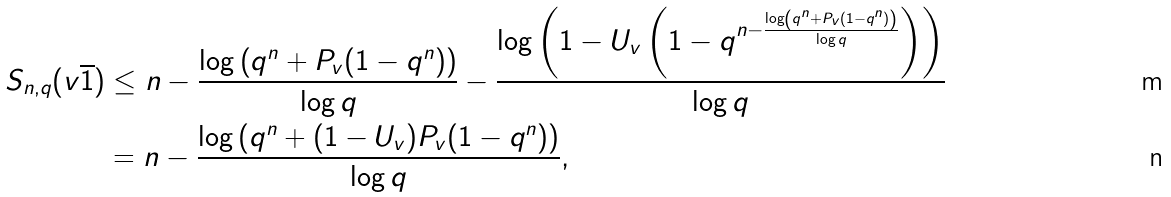Convert formula to latex. <formula><loc_0><loc_0><loc_500><loc_500>S _ { n , q } ( v \overline { 1 } ) & \leq n - \frac { \log \left ( q ^ { n } + P _ { v } ( 1 - q ^ { n } ) \right ) } { \log q } - \frac { \log \left ( 1 - U _ { v } \left ( 1 - q ^ { n - \frac { \log \left ( q ^ { n } + P _ { v } ( 1 - q ^ { n } ) \right ) } { \log q } } \right ) \right ) } { \log q } \\ & = n - \frac { \log \left ( q ^ { n } + ( 1 - U _ { v } ) P _ { v } ( 1 - q ^ { n } ) \right ) } { \log q } ,</formula> 